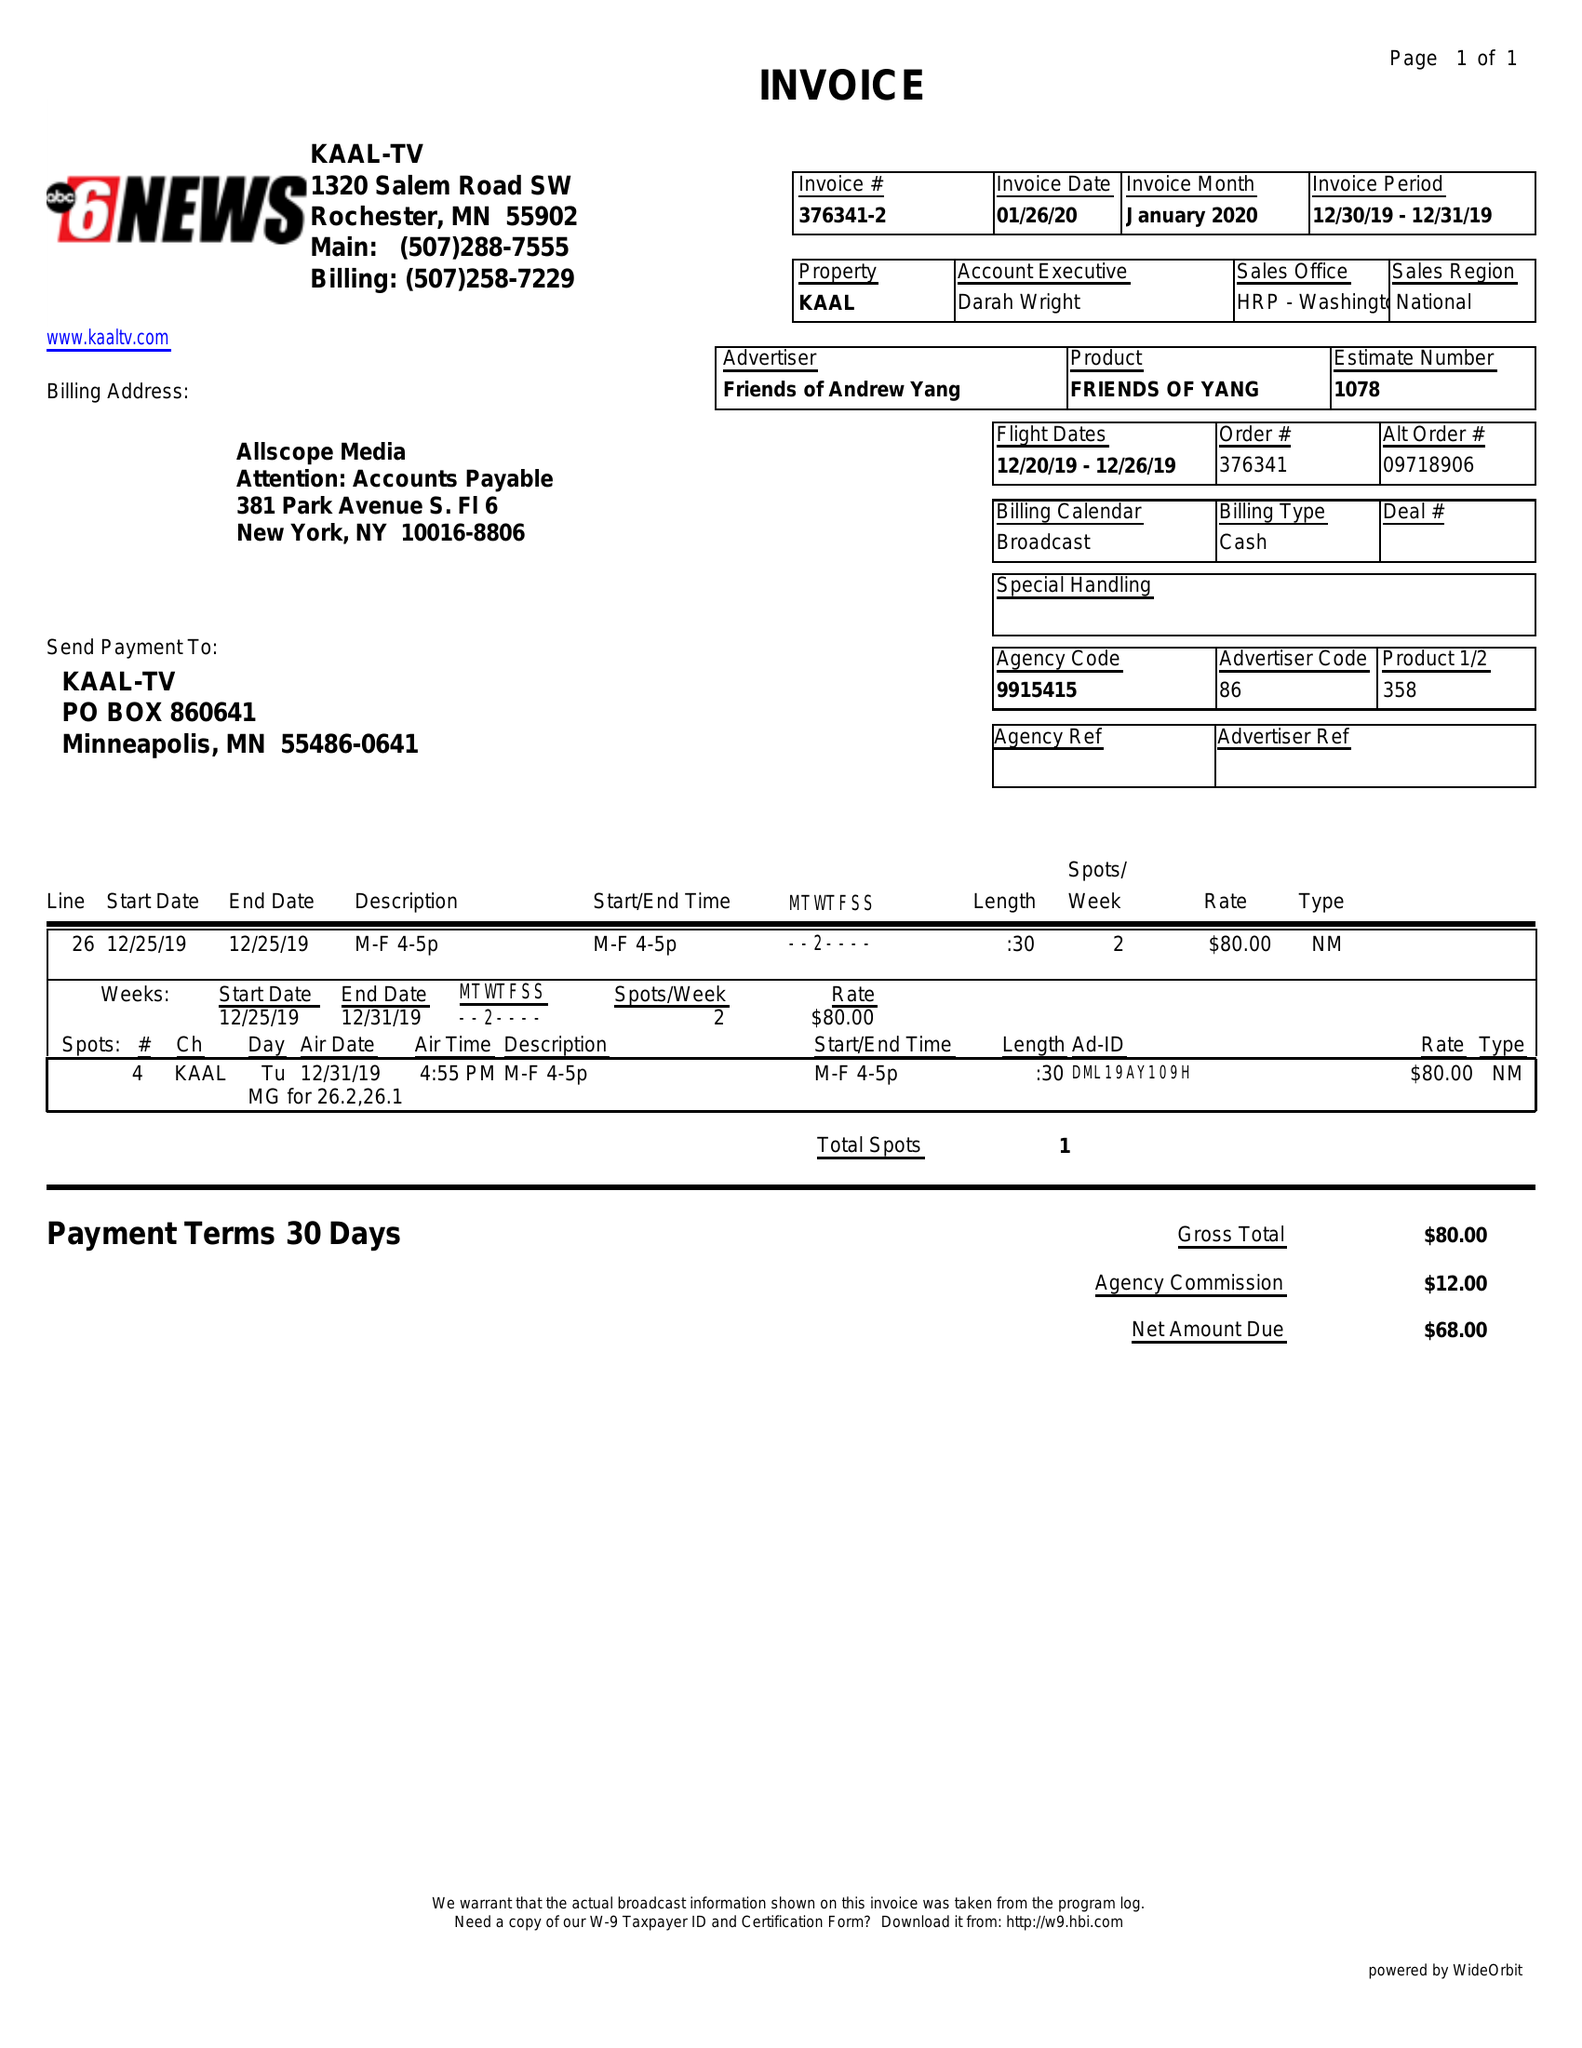What is the value for the advertiser?
Answer the question using a single word or phrase. FRIENDS OF ANDREW YANG 